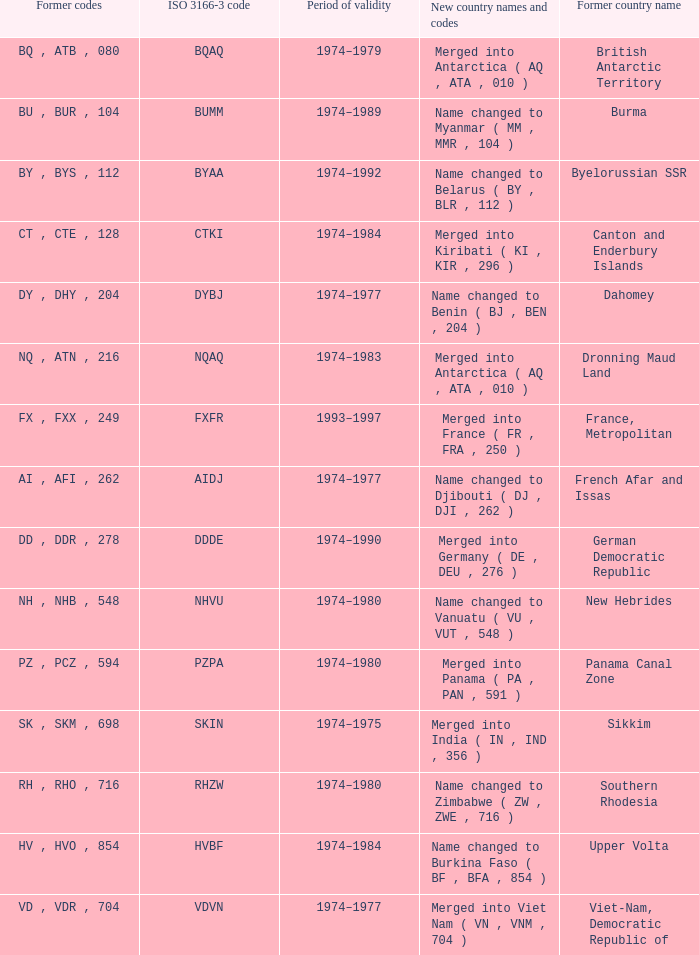Name the total number for period of validity for upper volta 1.0. 